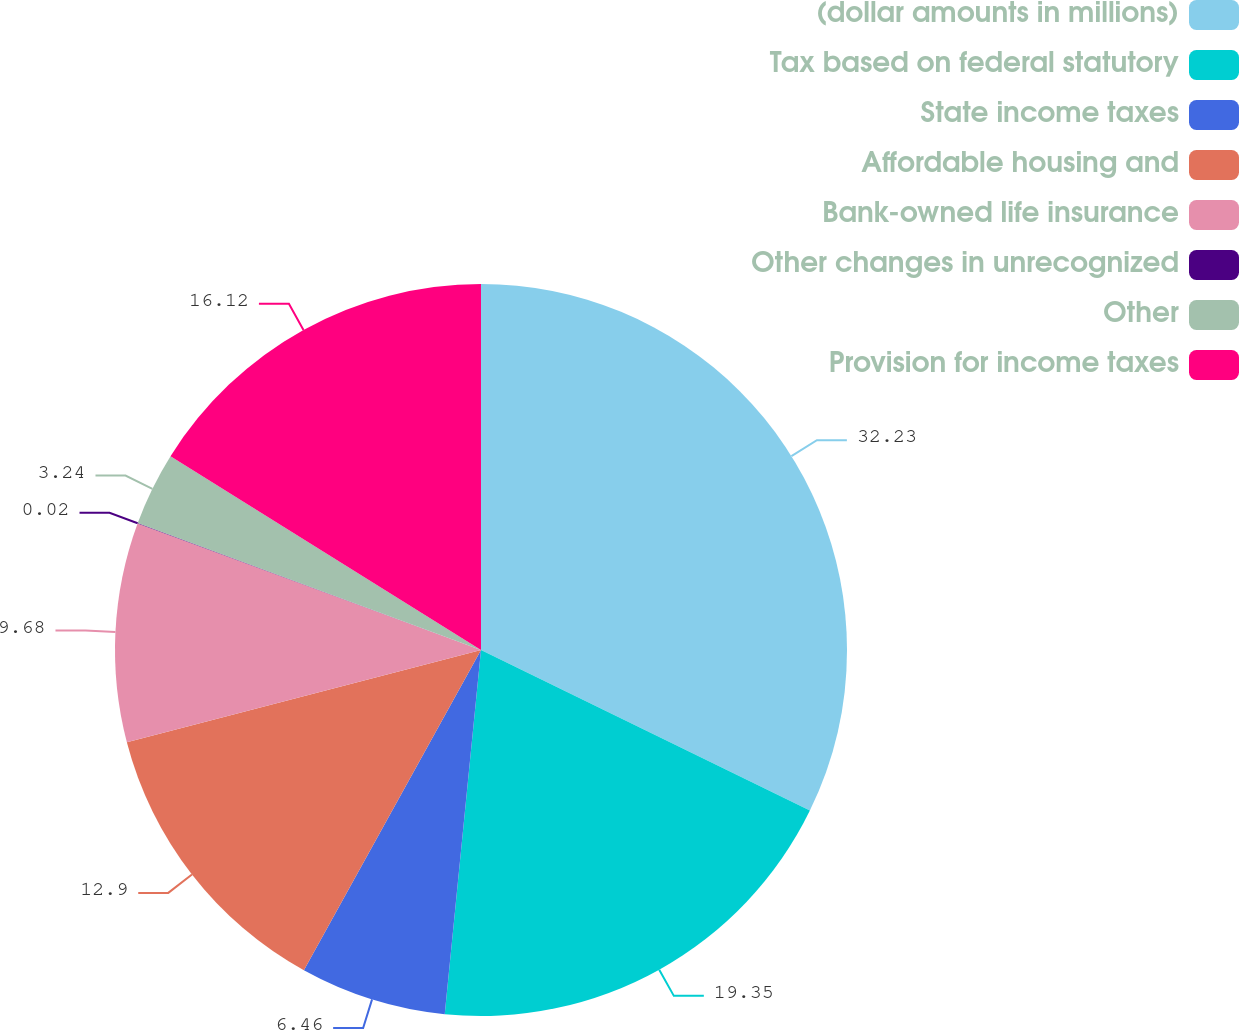<chart> <loc_0><loc_0><loc_500><loc_500><pie_chart><fcel>(dollar amounts in millions)<fcel>Tax based on federal statutory<fcel>State income taxes<fcel>Affordable housing and<fcel>Bank-owned life insurance<fcel>Other changes in unrecognized<fcel>Other<fcel>Provision for income taxes<nl><fcel>32.23%<fcel>19.35%<fcel>6.46%<fcel>12.9%<fcel>9.68%<fcel>0.02%<fcel>3.24%<fcel>16.12%<nl></chart> 